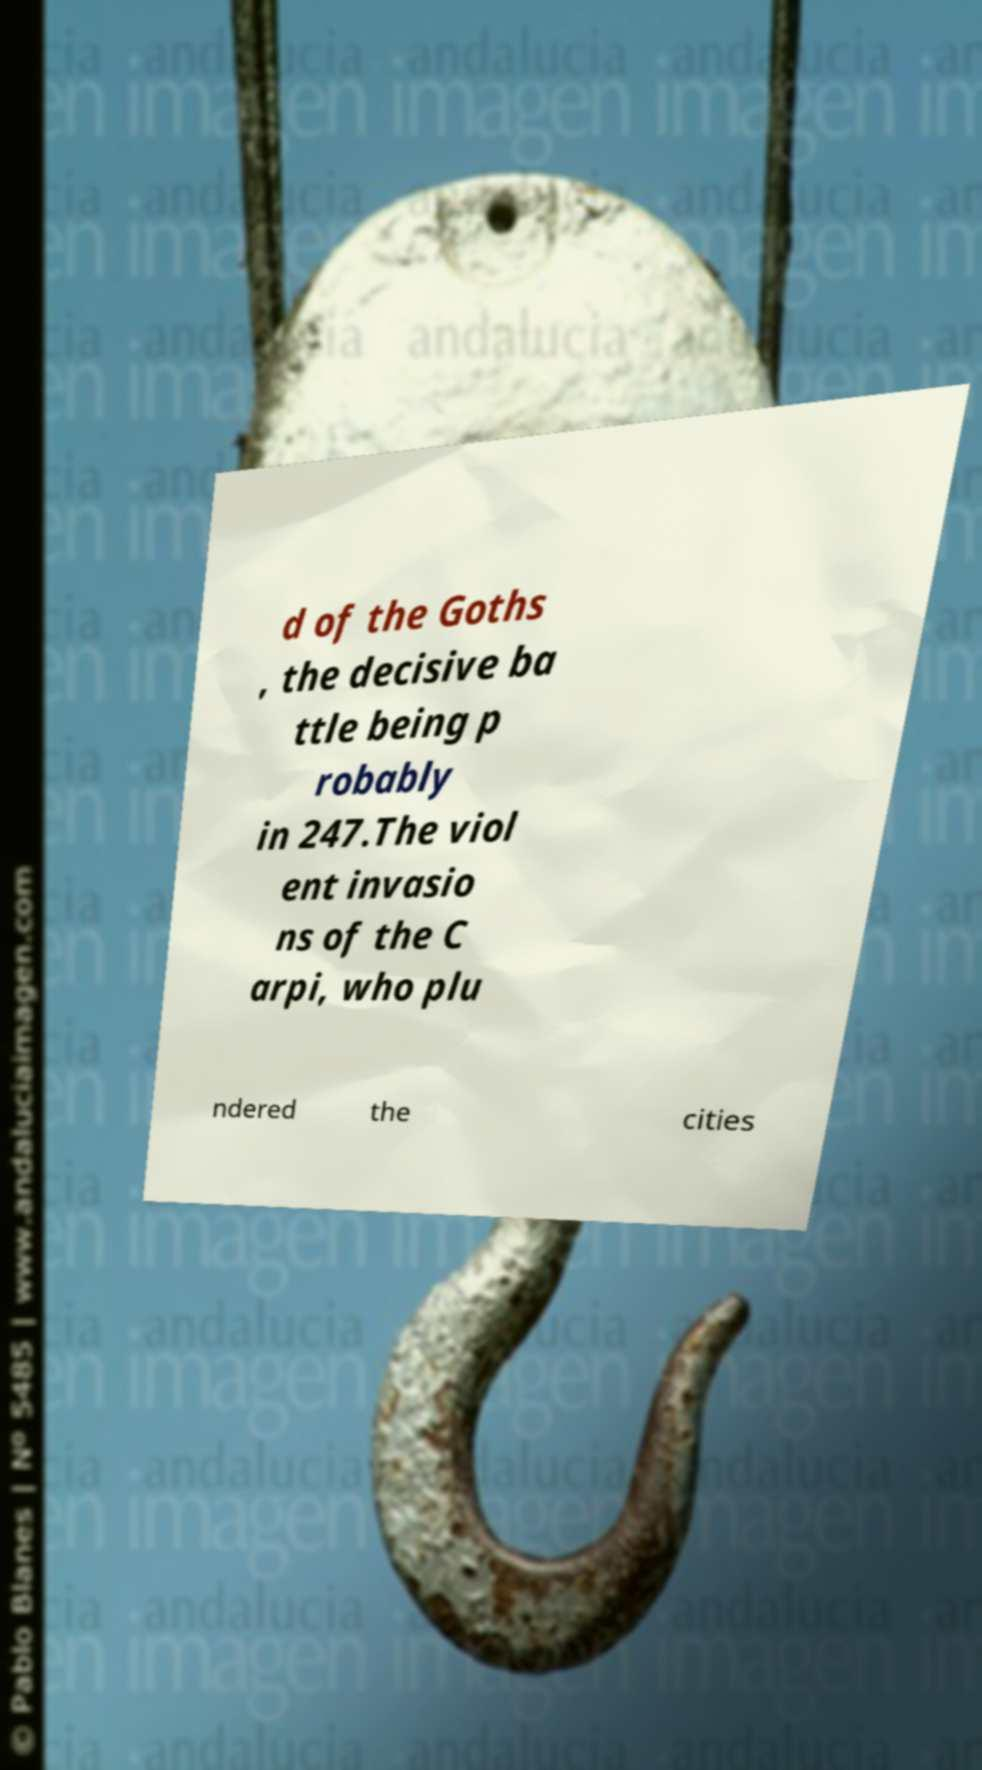Please identify and transcribe the text found in this image. d of the Goths , the decisive ba ttle being p robably in 247.The viol ent invasio ns of the C arpi, who plu ndered the cities 